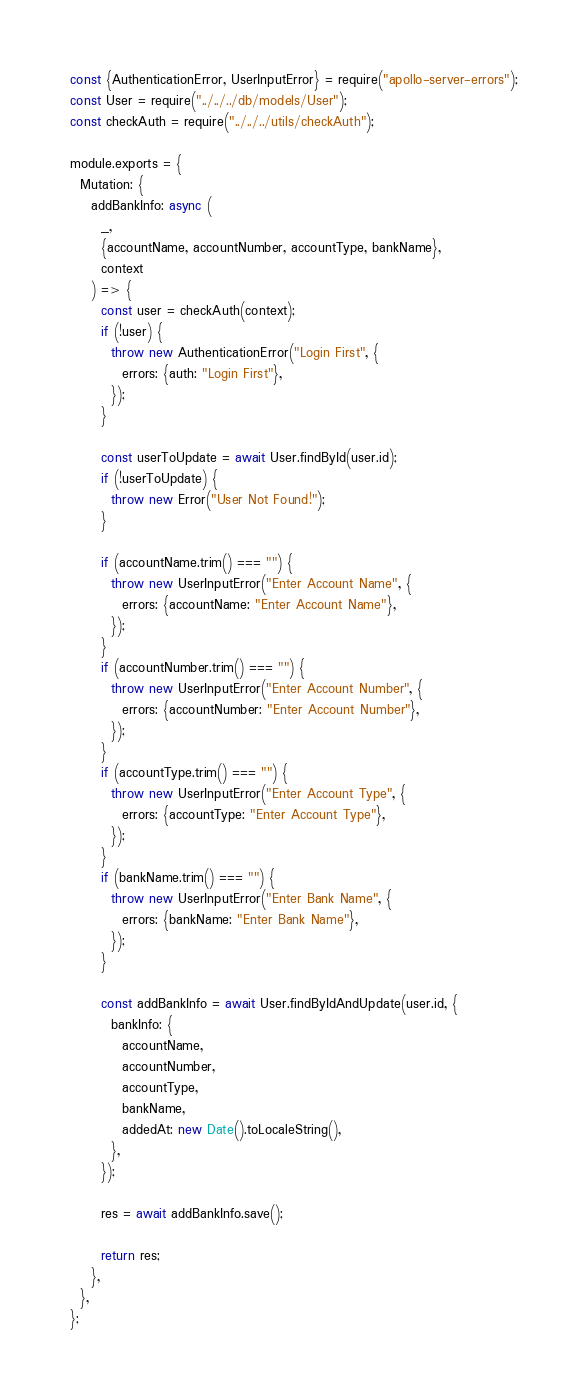<code> <loc_0><loc_0><loc_500><loc_500><_JavaScript_>const {AuthenticationError, UserInputError} = require("apollo-server-errors");
const User = require("../../../db/models/User");
const checkAuth = require("../../../utils/checkAuth");

module.exports = {
  Mutation: {
    addBankInfo: async (
      _,
      {accountName, accountNumber, accountType, bankName},
      context
    ) => {
      const user = checkAuth(context);
      if (!user) {
        throw new AuthenticationError("Login First", {
          errors: {auth: "Login First"},
        });
      }

      const userToUpdate = await User.findById(user.id);
      if (!userToUpdate) {
        throw new Error("User Not Found!");
      }

      if (accountName.trim() === "") {
        throw new UserInputError("Enter Account Name", {
          errors: {accountName: "Enter Account Name"},
        });
      }
      if (accountNumber.trim() === "") {
        throw new UserInputError("Enter Account Number", {
          errors: {accountNumber: "Enter Account Number"},
        });
      }
      if (accountType.trim() === "") {
        throw new UserInputError("Enter Account Type", {
          errors: {accountType: "Enter Account Type"},
        });
      }
      if (bankName.trim() === "") {
        throw new UserInputError("Enter Bank Name", {
          errors: {bankName: "Enter Bank Name"},
        });
      }

      const addBankInfo = await User.findByIdAndUpdate(user.id, {
        bankInfo: {
          accountName,
          accountNumber,
          accountType,
          bankName,
          addedAt: new Date().toLocaleString(),
        },
      });

      res = await addBankInfo.save();

      return res;
    },
  },
};
</code> 